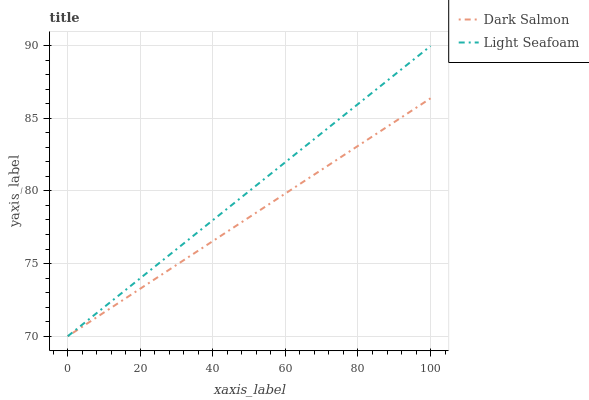Does Dark Salmon have the minimum area under the curve?
Answer yes or no. Yes. Does Light Seafoam have the maximum area under the curve?
Answer yes or no. Yes. Does Dark Salmon have the maximum area under the curve?
Answer yes or no. No. Is Dark Salmon the smoothest?
Answer yes or no. Yes. Is Light Seafoam the roughest?
Answer yes or no. Yes. Is Dark Salmon the roughest?
Answer yes or no. No. Does Light Seafoam have the highest value?
Answer yes or no. Yes. Does Dark Salmon have the highest value?
Answer yes or no. No. Does Dark Salmon intersect Light Seafoam?
Answer yes or no. Yes. Is Dark Salmon less than Light Seafoam?
Answer yes or no. No. Is Dark Salmon greater than Light Seafoam?
Answer yes or no. No. 